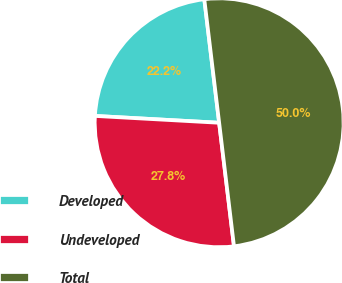Convert chart. <chart><loc_0><loc_0><loc_500><loc_500><pie_chart><fcel>Developed<fcel>Undeveloped<fcel>Total<nl><fcel>22.22%<fcel>27.78%<fcel>50.0%<nl></chart> 